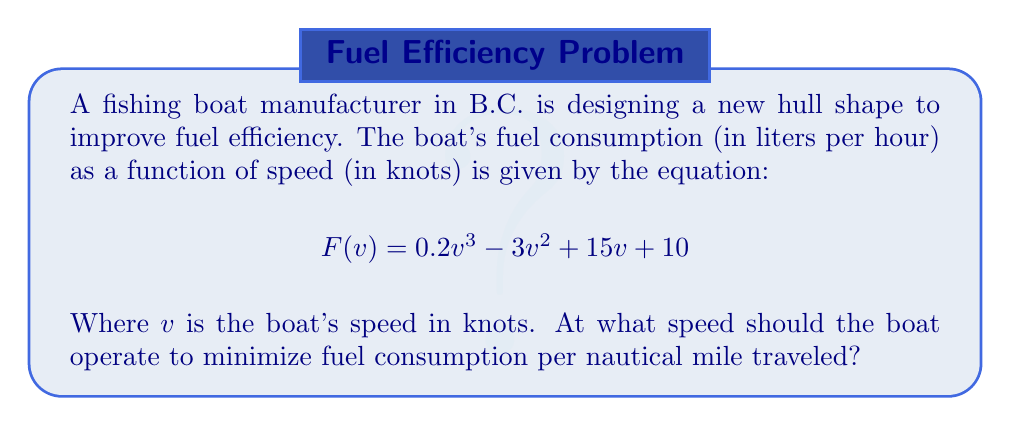What is the answer to this math problem? To find the speed that minimizes fuel consumption per nautical mile, we need to minimize the function $G(v) = \frac{F(v)}{v}$, which represents liters of fuel per nautical mile.

1) First, let's express $G(v)$:
   $$G(v) = \frac{F(v)}{v} = \frac{0.2v^3 - 3v^2 + 15v + 10}{v} = 0.2v^2 - 3v + 15 + \frac{10}{v}$$

2) To find the minimum, we need to find where $G'(v) = 0$:
   $$G'(v) = 0.4v - 3 - \frac{10}{v^2}$$

3) Set $G'(v) = 0$ and solve:
   $$0.4v - 3 - \frac{10}{v^2} = 0$$
   $$0.4v^3 - 3v^2 - 10 = 0$$

4) This is a cubic equation. It can be solved using the cubic formula or numerical methods. Using a numerical solver, we find that the only positive real solution is approximately:
   $$v \approx 5.8276 \text{ knots}$$

5) To confirm this is a minimum, we can check the second derivative is positive at this point:
   $$G''(v) = 0.4 + \frac{20}{v^3}$$
   At $v \approx 5.8276$, $G''(v) > 0$, confirming a local minimum.
Answer: 5.8276 knots 